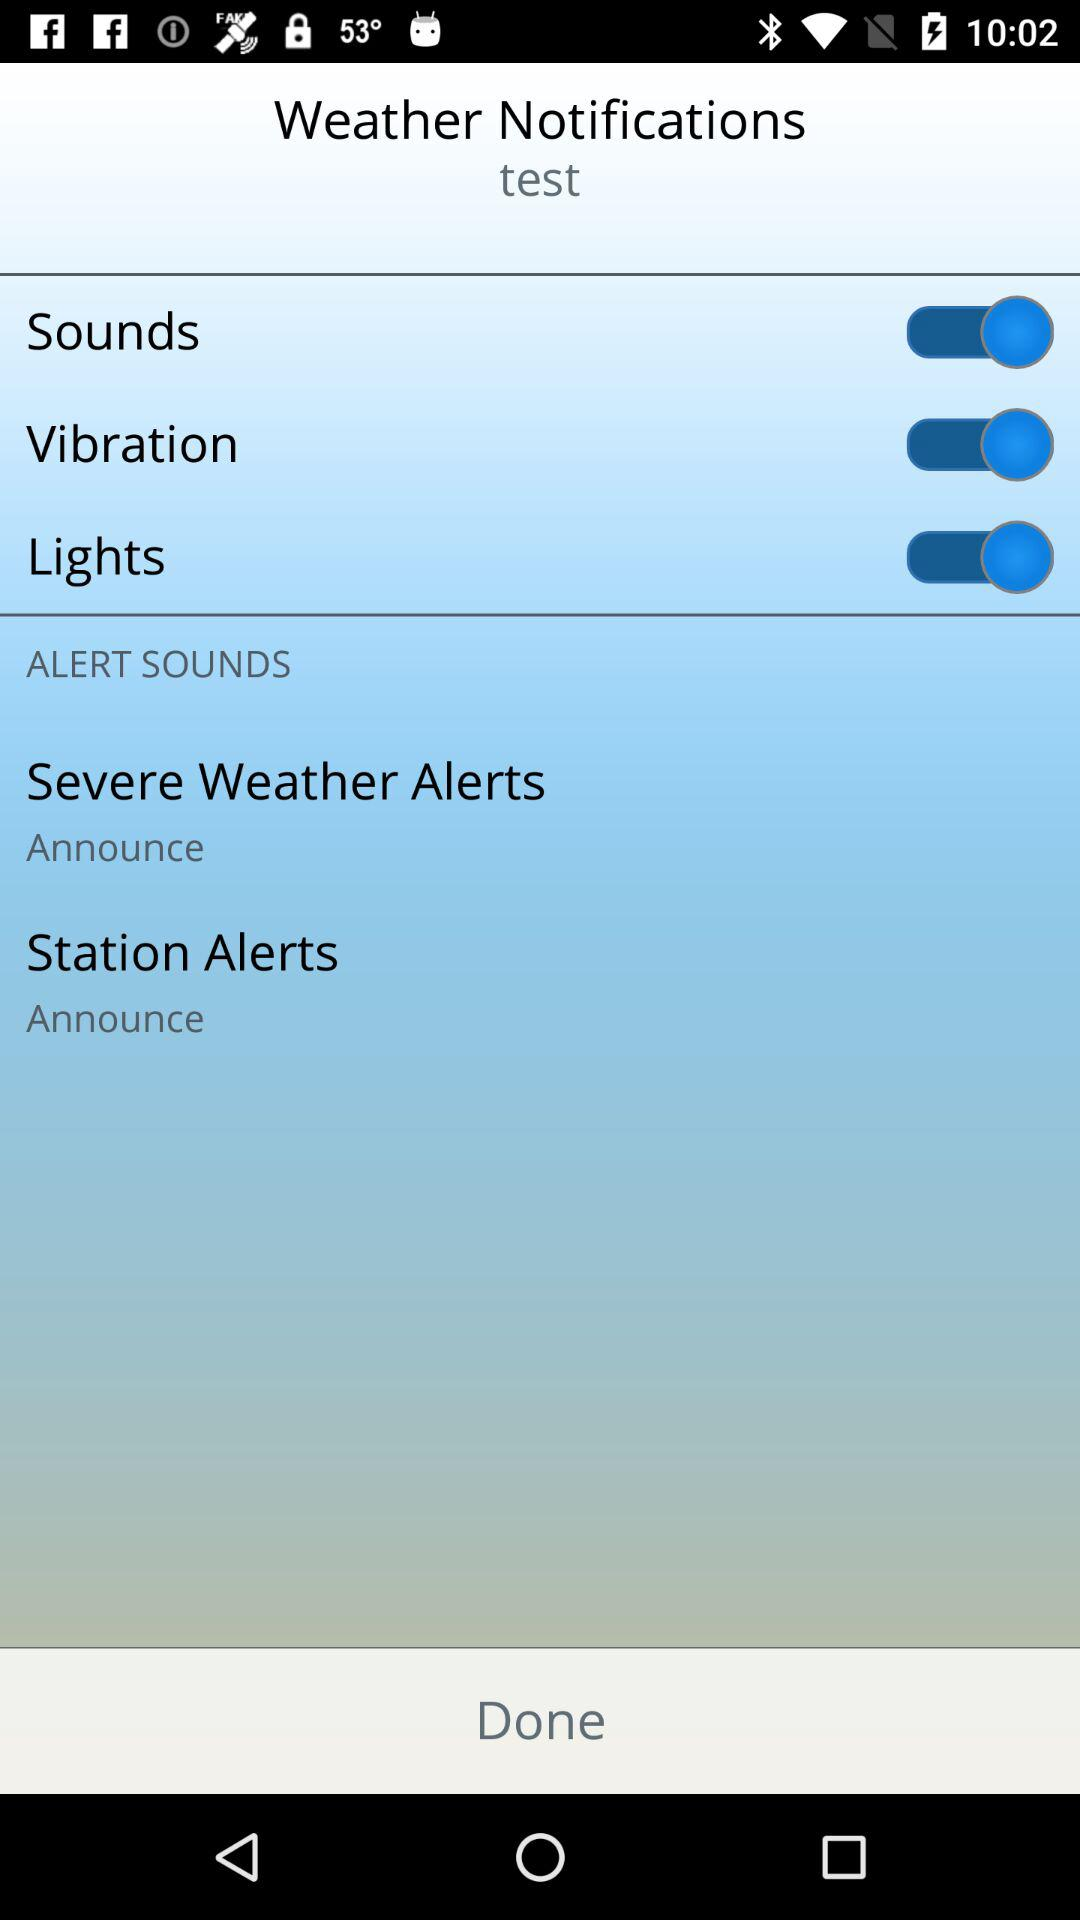How many more alerts are there than sounds?
Answer the question using a single word or phrase. 2 